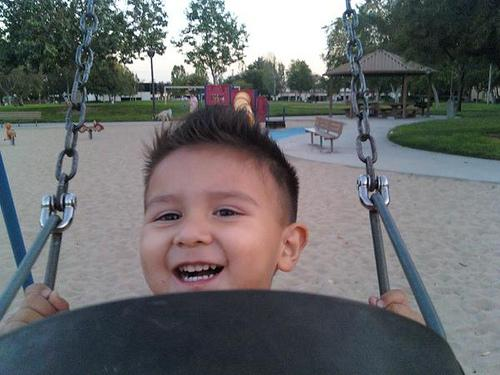Question: what is the little boy's expression?
Choices:
A. Frowning.
B. Curious.
C. Smiling.
D. Sad.
Answer with the letter. Answer: C Question: what equipment is the boy using?
Choices:
A. Jump rope.
B. Pogo stick.
C. Swing.
D. Bicycle.
Answer with the letter. Answer: C Question: where was this picture taken?
Choices:
A. Outdoors.
B. Backyard.
C. Playground.
D. School.
Answer with the letter. Answer: C Question: who is in the picture?
Choices:
A. Children.
B. A girl.
C. Little boy.
D. Baby.
Answer with the letter. Answer: C Question: what is covering the ground around the swing?
Choices:
A. Sand.
B. Snow.
C. Grass.
D. Weeds.
Answer with the letter. Answer: A 